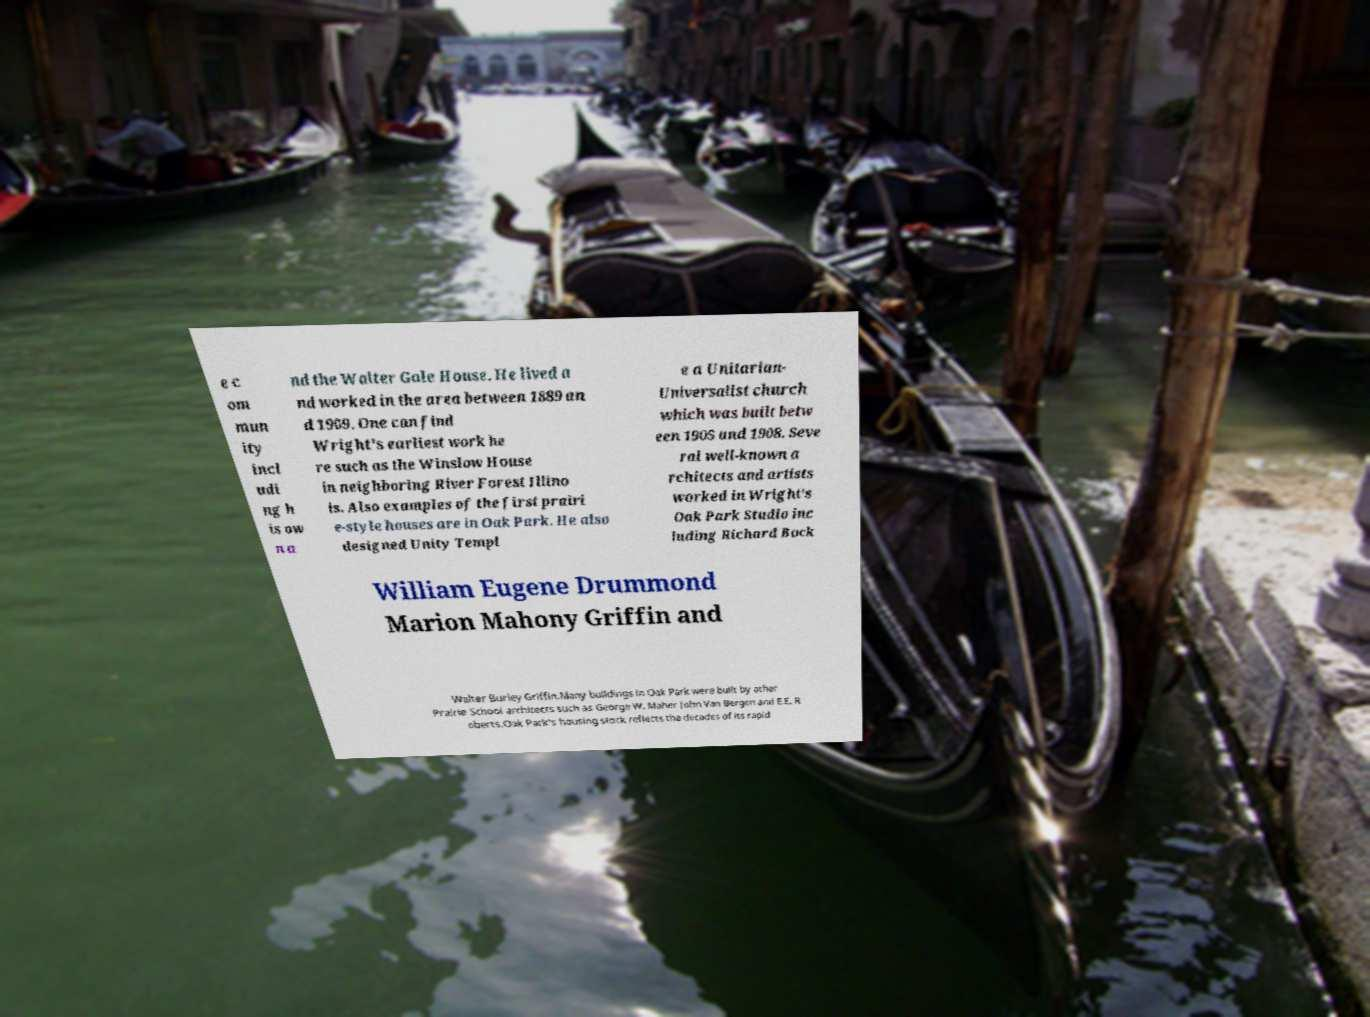What messages or text are displayed in this image? I need them in a readable, typed format. e c om mun ity incl udi ng h is ow n a nd the Walter Gale House. He lived a nd worked in the area between 1889 an d 1909. One can find Wright's earliest work he re such as the Winslow House in neighboring River Forest Illino is. Also examples of the first prairi e-style houses are in Oak Park. He also designed Unity Templ e a Unitarian- Universalist church which was built betw een 1905 and 1908. Seve ral well-known a rchitects and artists worked in Wright's Oak Park Studio inc luding Richard Bock William Eugene Drummond Marion Mahony Griffin and Walter Burley Griffin.Many buildings in Oak Park were built by other Prairie School architects such as George W. Maher John Van Bergen and E.E. R oberts.Oak Park's housing stock reflects the decades of its rapid 